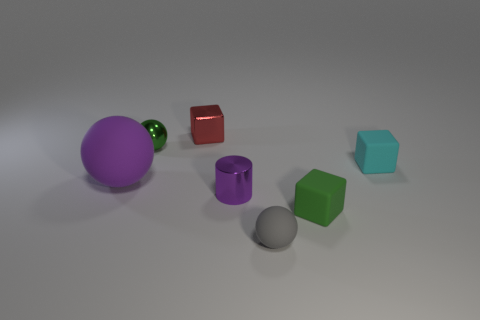Add 1 yellow rubber blocks. How many objects exist? 8 Subtract all cubes. How many objects are left? 4 Add 7 small gray rubber balls. How many small gray rubber balls are left? 8 Add 2 large purple rubber spheres. How many large purple rubber spheres exist? 3 Subtract 0 brown cylinders. How many objects are left? 7 Subtract all brown matte things. Subtract all big matte objects. How many objects are left? 6 